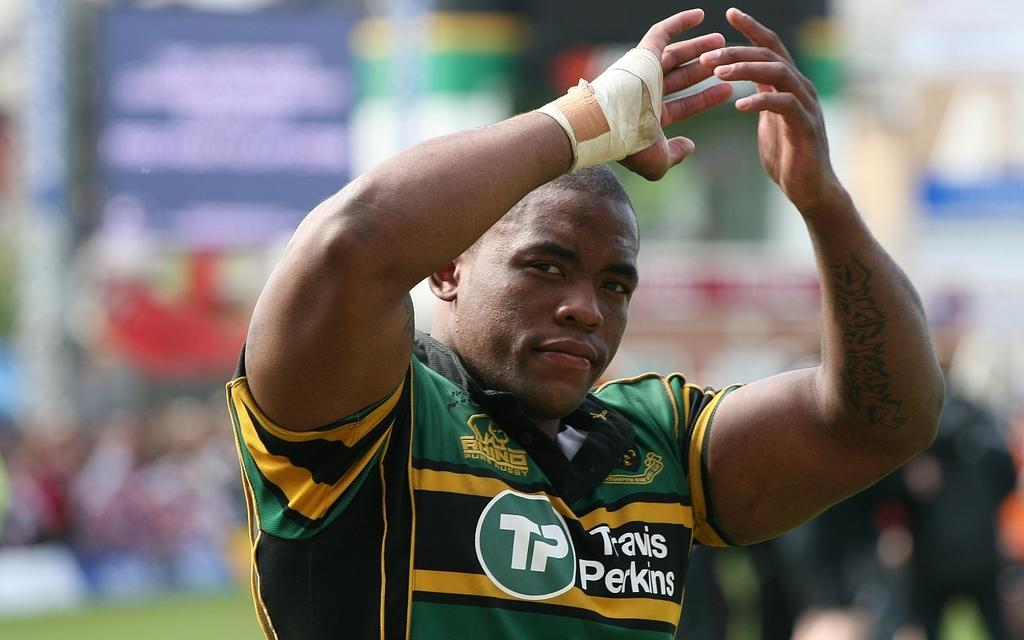<image>
Summarize the visual content of the image. Man clappiing his hands while wearing a shirt which says Travis Perkins. 